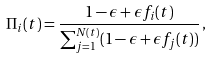Convert formula to latex. <formula><loc_0><loc_0><loc_500><loc_500>\Pi _ { i } ( t ) = \frac { 1 - \epsilon + \epsilon f _ { i } ( t ) } { \sum _ { j = 1 } ^ { N ( t ) } ( 1 - \epsilon + \epsilon f _ { j } ( t ) ) } \, ,</formula> 